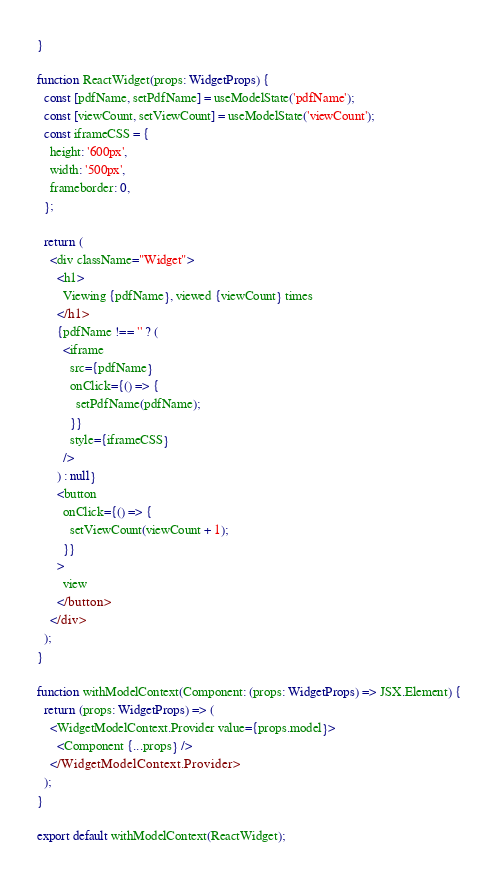<code> <loc_0><loc_0><loc_500><loc_500><_TypeScript_>}

function ReactWidget(props: WidgetProps) {
  const [pdfName, setPdfName] = useModelState('pdfName');
  const [viewCount, setViewCount] = useModelState('viewCount');
  const iframeCSS = {
    height: '600px',
    width: '500px',
    frameborder: 0,
  };

  return (
    <div className="Widget">
      <h1>
        Viewing {pdfName}, viewed {viewCount} times
      </h1>
      {pdfName !== '' ? (
        <iframe
          src={pdfName}
          onClick={() => {
            setPdfName(pdfName);
          }}
          style={iframeCSS}
        />
      ) : null}
      <button
        onClick={() => {
          setViewCount(viewCount + 1);
        }}
      >
        view
      </button>
    </div>
  );
}

function withModelContext(Component: (props: WidgetProps) => JSX.Element) {
  return (props: WidgetProps) => (
    <WidgetModelContext.Provider value={props.model}>
      <Component {...props} />
    </WidgetModelContext.Provider>
  );
}

export default withModelContext(ReactWidget);
</code> 